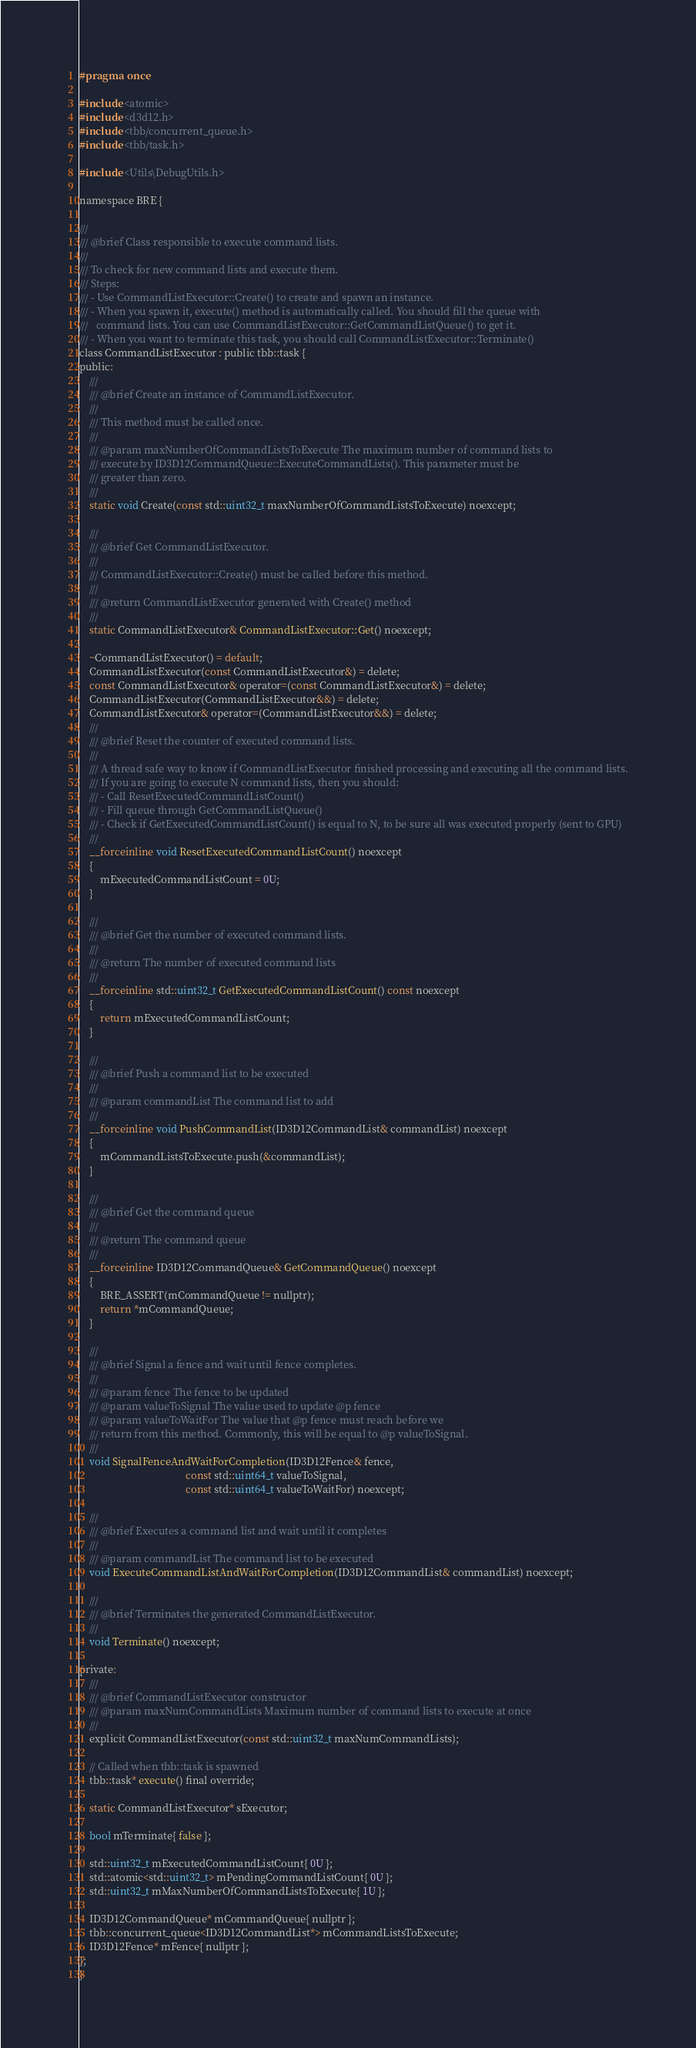Convert code to text. <code><loc_0><loc_0><loc_500><loc_500><_C_>#pragma once

#include <atomic>
#include <d3d12.h>
#include <tbb/concurrent_queue.h>
#include <tbb/task.h>

#include <Utils\DebugUtils.h>

namespace BRE {

///
/// @brief Class responsible to execute command lists.
///
/// To check for new command lists and execute them.
/// Steps:
/// - Use CommandListExecutor::Create() to create and spawn an instance.
/// - When you spawn it, execute() method is automatically called. You should fill the queue with
///   command lists. You can use CommandListExecutor::GetCommandListQueue() to get it.
/// - When you want to terminate this task, you should call CommandListExecutor::Terminate() 
class CommandListExecutor : public tbb::task {
public:
    ///
    /// @brief Create an instance of CommandListExecutor. 
    ///
    /// This method must be called once.
    ///
    /// @param maxNumberOfCommandListsToExecute The maximum number of command lists to
    /// execute by ID3D12CommandQueue::ExecuteCommandLists(). This parameter must be
    /// greater than zero.
    ///
    static void Create(const std::uint32_t maxNumberOfCommandListsToExecute) noexcept;

    ///
    /// @brief Get CommandListExecutor. 
    ///
    /// CommandListExecutor::Create() must be called before this method.
    ///
    /// @return CommandListExecutor generated with Create() method
    ///
    static CommandListExecutor& CommandListExecutor::Get() noexcept;

    ~CommandListExecutor() = default;
    CommandListExecutor(const CommandListExecutor&) = delete;
    const CommandListExecutor& operator=(const CommandListExecutor&) = delete;
    CommandListExecutor(CommandListExecutor&&) = delete;
    CommandListExecutor& operator=(CommandListExecutor&&) = delete;
    ///
    /// @brief Reset the counter of executed command lists.
    ///
    /// A thread safe way to know if CommandListExecutor finished processing and executing all the command lists.
    /// If you are going to execute N command lists, then you should:
    /// - Call ResetExecutedCommandListCount()
    /// - Fill queue through GetCommandListQueue()
    /// - Check if GetExecutedCommandListCount() is equal to N, to be sure all was executed properly (sent to GPU)
    ///
    __forceinline void ResetExecutedCommandListCount() noexcept
    {
        mExecutedCommandListCount = 0U;
    }

    ///
    /// @brief Get the number of executed command lists.
    ///
    /// @return The number of executed command lists
    ///
    __forceinline std::uint32_t GetExecutedCommandListCount() const noexcept
    {
        return mExecutedCommandListCount;
    }

    ///
    /// @brief Push a command list to be executed
    ///
    /// @param commandList The command list to add
    ///
    __forceinline void PushCommandList(ID3D12CommandList& commandList) noexcept
    {
        mCommandListsToExecute.push(&commandList);
    }

    ///
    /// @brief Get the command queue
    ///
    /// @return The command queue
    ///
    __forceinline ID3D12CommandQueue& GetCommandQueue() noexcept
    {
        BRE_ASSERT(mCommandQueue != nullptr);
        return *mCommandQueue;
    }

    ///
    /// @brief Signal a fence and wait until fence completes.
    ///
    /// @param fence The fence to be updated
    /// @param valueToSignal The value used to update @p fence
    /// @param valueToWaitFor The value that @p fence must reach before we 
    /// return from this method. Commonly, this will be equal to @p valueToSignal.
    ///
    void SignalFenceAndWaitForCompletion(ID3D12Fence& fence,
                                         const std::uint64_t valueToSignal,
                                         const std::uint64_t valueToWaitFor) noexcept;

    ///
    /// @brief Executes a command list and wait until it completes
    ///
    /// @param commandList The command list to be executed
    void ExecuteCommandListAndWaitForCompletion(ID3D12CommandList& commandList) noexcept;

    ///
    /// @brief Terminates the generated CommandListExecutor.
    ///
    void Terminate() noexcept;

private:
    ///
    /// @brief CommandListExecutor constructor
    /// @param maxNumCommandLists Maximum number of command lists to execute at once
    ///
    explicit CommandListExecutor(const std::uint32_t maxNumCommandLists);

    // Called when tbb::task is spawned
    tbb::task* execute() final override;

    static CommandListExecutor* sExecutor;

    bool mTerminate{ false };

    std::uint32_t mExecutedCommandListCount{ 0U };
    std::atomic<std::uint32_t> mPendingCommandListCount{ 0U };
    std::uint32_t mMaxNumberOfCommandListsToExecute{ 1U };

    ID3D12CommandQueue* mCommandQueue{ nullptr };
    tbb::concurrent_queue<ID3D12CommandList*> mCommandListsToExecute;
    ID3D12Fence* mFence{ nullptr };
};
}</code> 